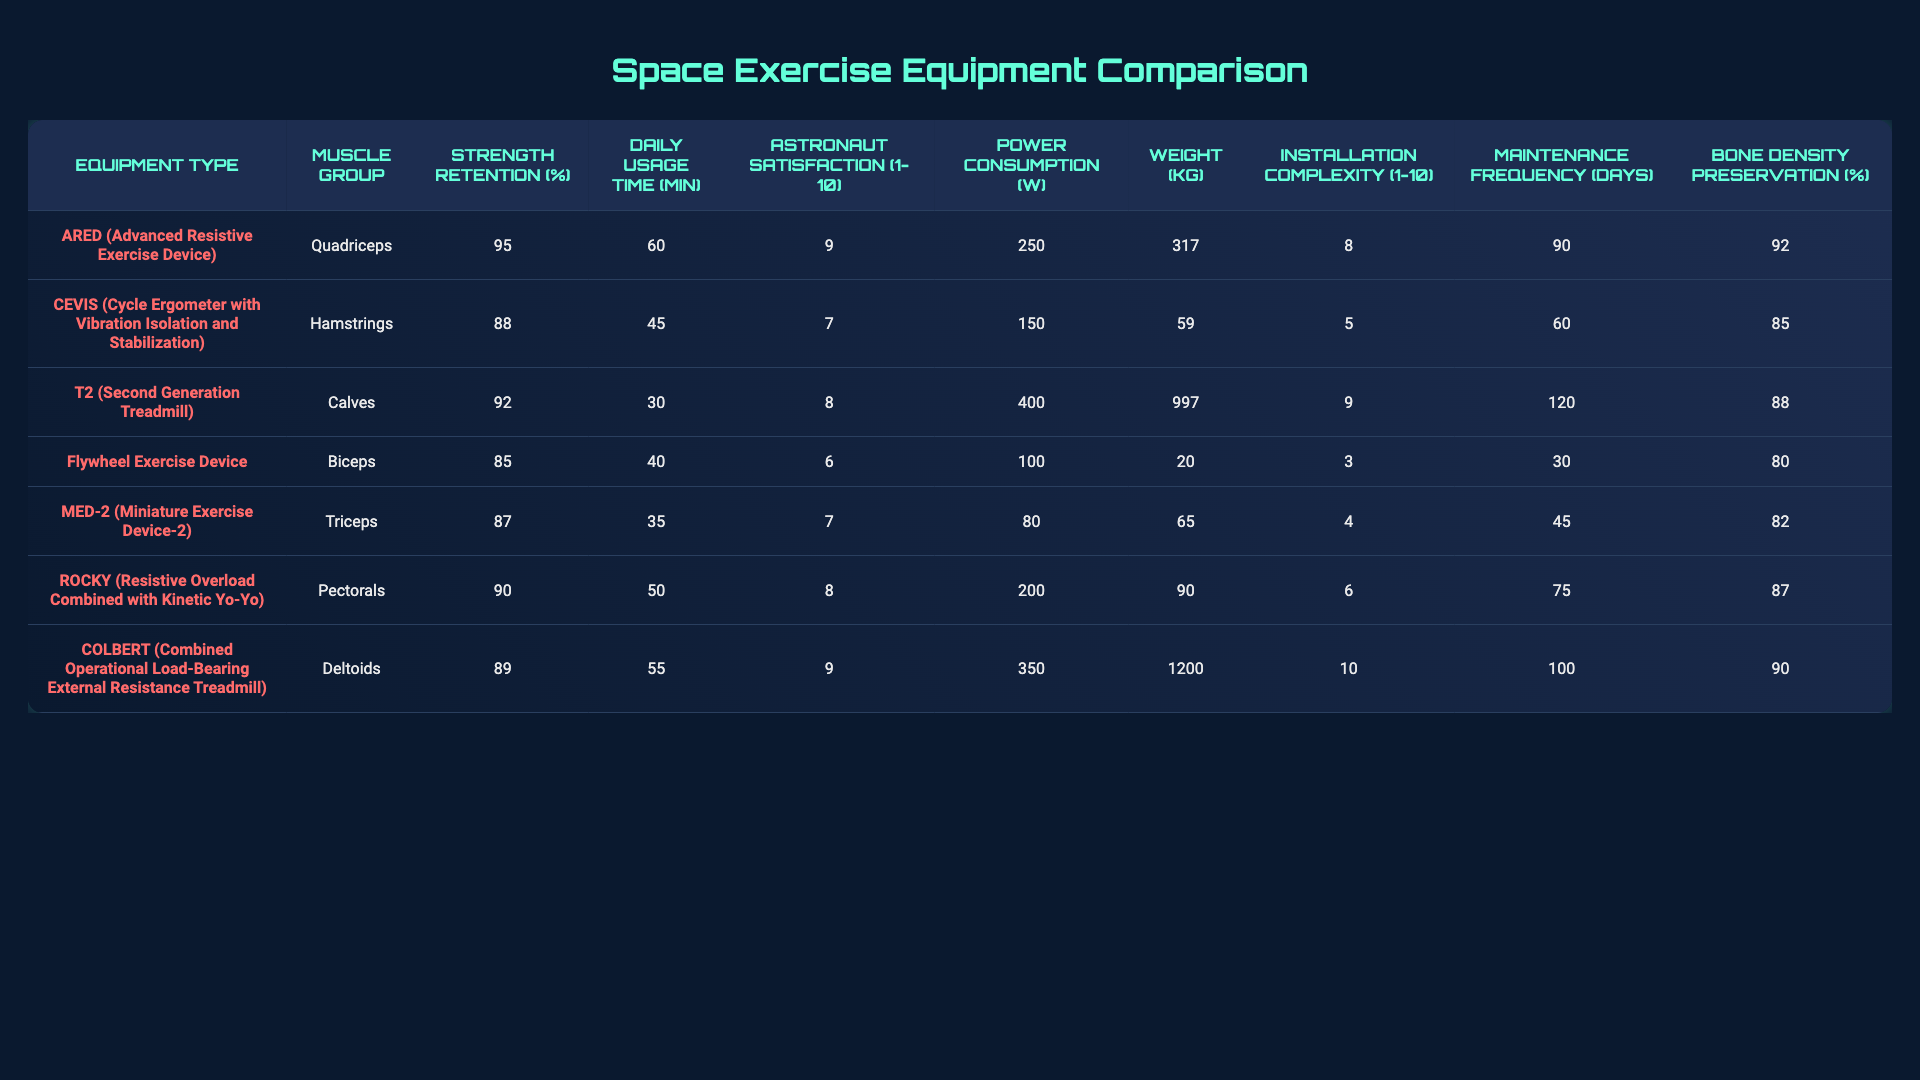What is the strength retention percentage for the ARED equipment? The table lists the strength retention percentage for ARED, which is directly provided in the corresponding row. It shows 95% for this equipment type.
Answer: 95% Which equipment has the highest astronaut satisfaction rating? By examining the astronaut satisfaction ratings across all equipment types listed, the ARED and COLBERT equipment both have a satisfaction rating of 9, which is the highest score.
Answer: ARED and COLBERT What is the average daily usage time for all equipment types? To find the average, sum up the daily usage times: (60 + 45 + 30 + 40 + 35 + 50 + 55) = 315 minutes. There are 7 equipment types, so the average daily usage time is 315/7 = 45 minutes.
Answer: 45 minutes Is the power consumption of the T2 higher than the power consumption of the Flywheel Exercise Device? The power consumption for T2 is 400 Watts. For the Flywheel Exercise Device, it is 100 Watts. Since 400 is greater than 100, the statement is true.
Answer: Yes What is the difference in strength retention percentage between the equipment with the highest and the lowest strength retention? From the table, ARED has the highest strength retention at 95%, and the Flywheel Exercise Device has the lowest at 85%. The difference is 95 - 85 = 10%.
Answer: 10% Which equipment has the lowest installation complexity rating and what is that rating? The installation complexity for the Flywheel Exercise Device is given as 3, which is lower than all other ratings in the table.
Answer: 3 How do the weight and power consumption compare for the CEVIS equipment? The weight of CEVIS is 59 kg and its power consumption is 150 Watts. If we just look at the values, both are among the lowest in their respective categories.
Answer: Weight: 59 kg, Power Consumption: 150 Watts Can you provide the bone density preservation percentage of the MED-2 equipment? The table shows that the bone density preservation percentage for MED-2 is listed as 82%. This information can be found directly in the corresponding row for MED-2.
Answer: 82% What is the total maintenance frequency in days for all equipment models combined? To find the total maintenance frequency, add all the numbers: (90 + 60 + 120 + 30 + 45 + 75 + 100) = 520 days.
Answer: 520 days Which equipment type resulted in the highest bone density preservation percentage, and what was that percentage? By examining the bone density preservation percentages for all equipment, we see that ARED has the highest at 92%. This is directly evident from the table.
Answer: 92% 